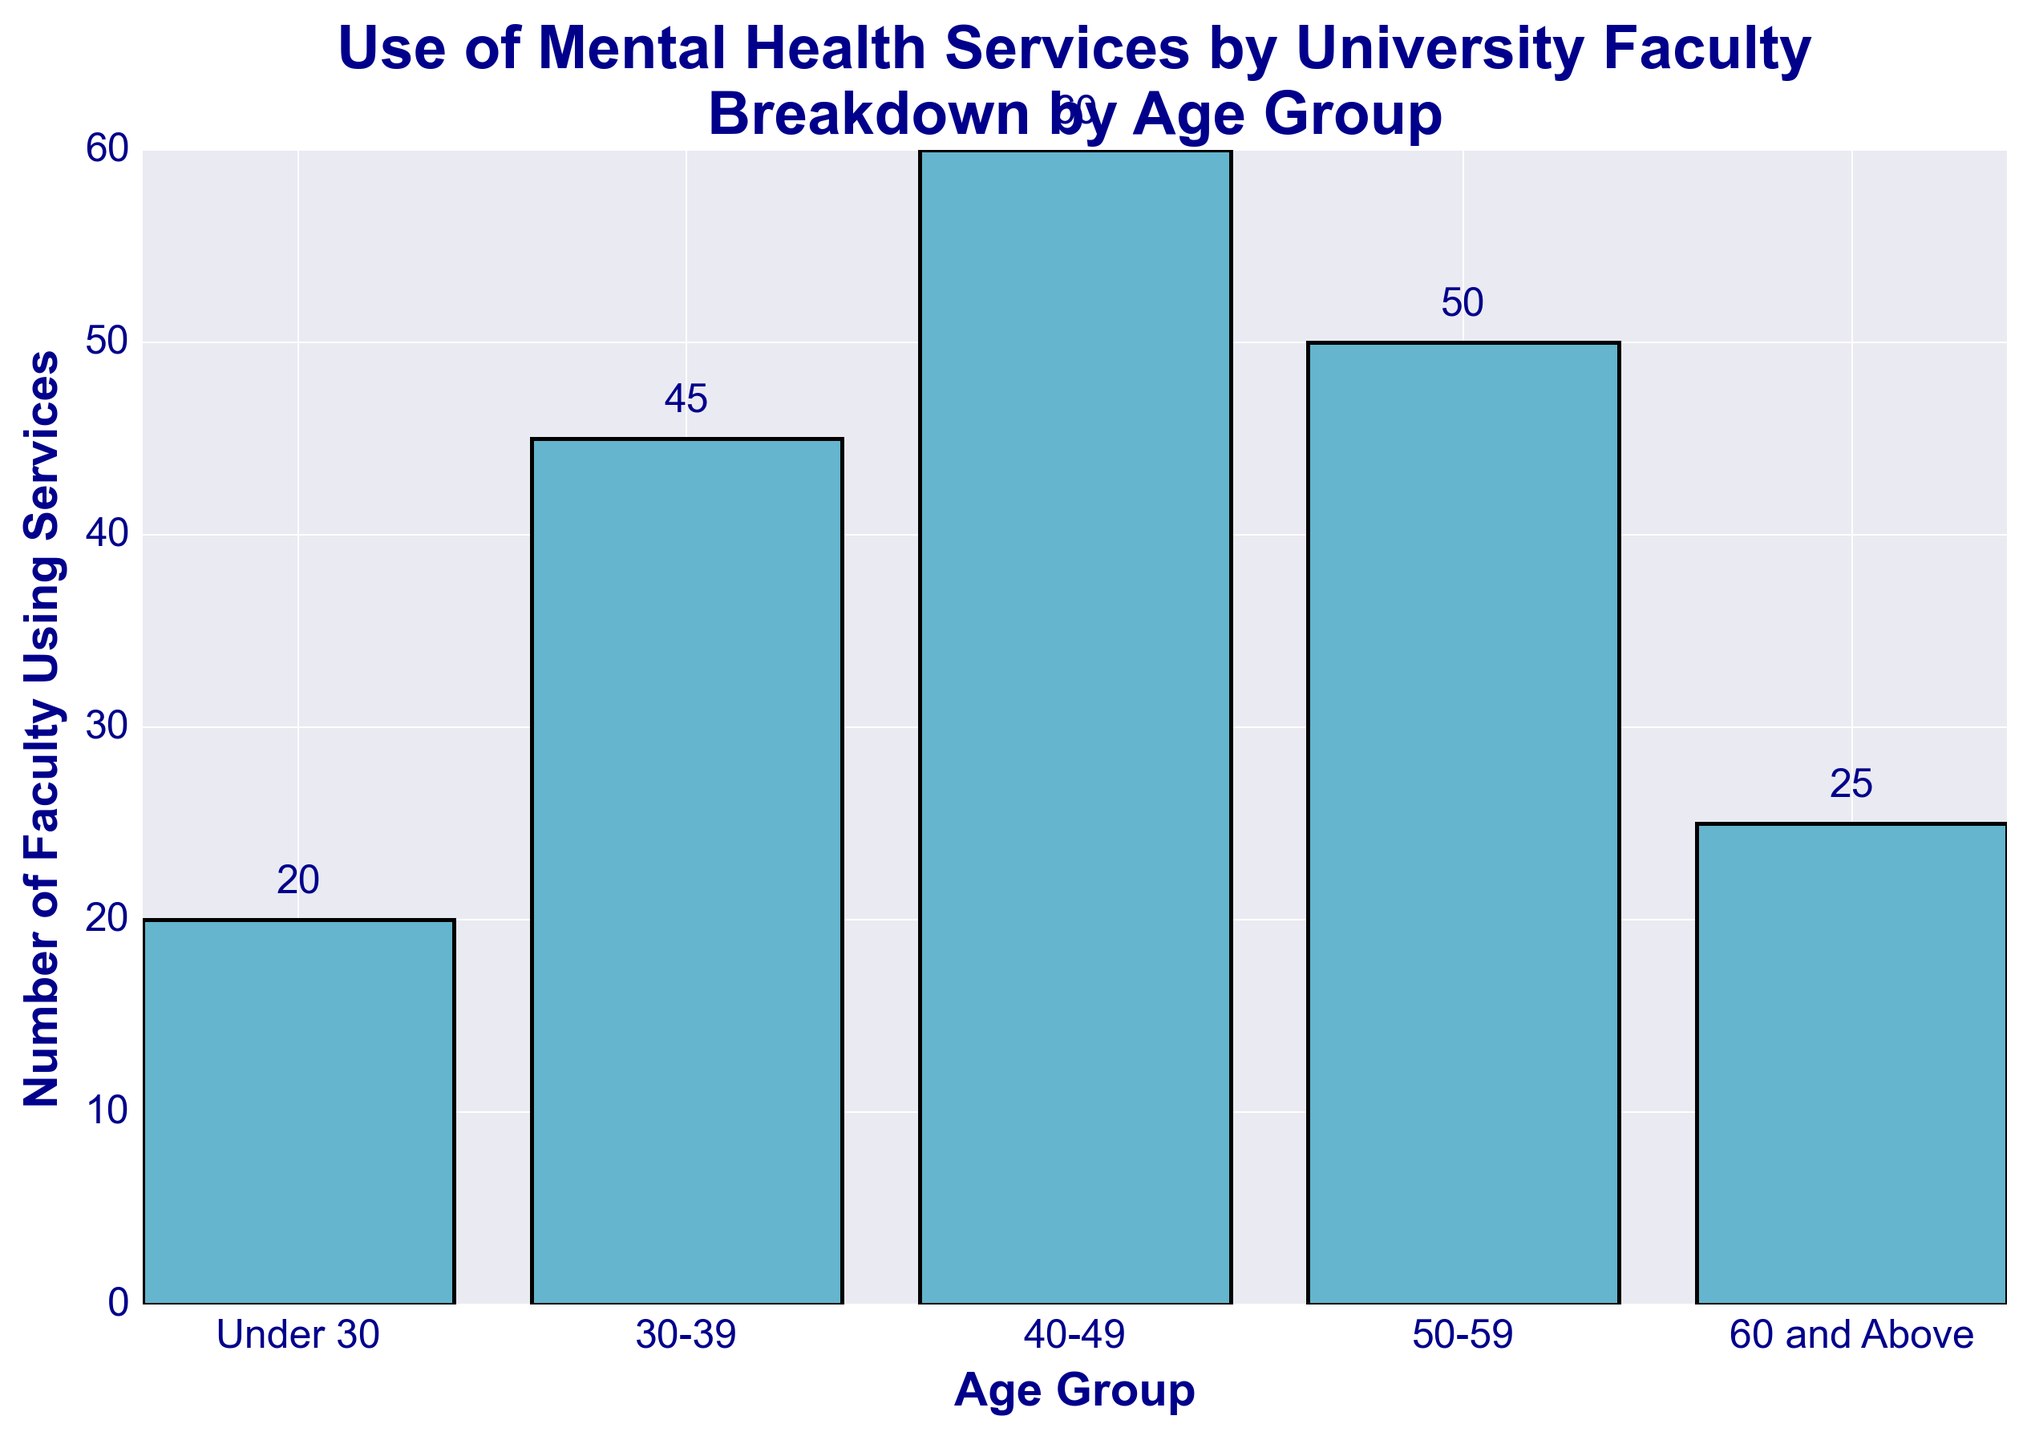what is the total number of faculty using mental health services? Sum all the values: 20 (Under 30) + 45 (30-39) + 60 (40-49) + 50 (50-59) + 25 (60 and Above) = 200
Answer: 200 which age group has the highest number of faculty using mental health services? Compare the heights of the bars in the figure: 60 (40-49) has the highest value.
Answer: 40-49 how much more faculty in the 40-49 age group use services compared to the under 30 age group? Subtract the number for Under 30 from the number for 40-49: 60 (40-49) - 20 (Under 30) = 40
Answer: 40 which age group has fewer faculty using mental health services, 50-59 or 60 and Above? Compare the values for the two age groups: 25 (60 and Above) < 50 (50-59)
Answer: 60 and Above what is the average number of faculty using mental health services across all age groups? Add all values and divide by the number of groups: (20 + 45 + 60 + 50 + 25) / 5 = 200 / 5 = 40
Answer: 40 what percentage of the total faculty using services does the 30-39 age group represent? Calculate the percentage: (45 / 200) * 100 = 22.5%
Answer: 22.5% how does the usage of mental health services in the 50-59 age group compare to the 30-39 age group? Compare the values for the two groups: 50 (50-59) > 45 (30-39)
Answer: 50-59 is greater what is the difference in the number of faculty using mental health services between the 40-49 and 50-59 age groups? Subtract the number for 50-59 from the number for 40-49: 60 (40-49) - 50 (50-59) = 10
Answer: 10 what is the median number of faculty using mental health services across all age groups? Order the values and find the middle one: 20, 25, 45, 50, 60. The median is 45.
Answer: 45 which age group has the second highest number of faculty using mental health services? Identify the second largest value: 50 (50-59) is the second highest after 60 (40-49).
Answer: 50-59 